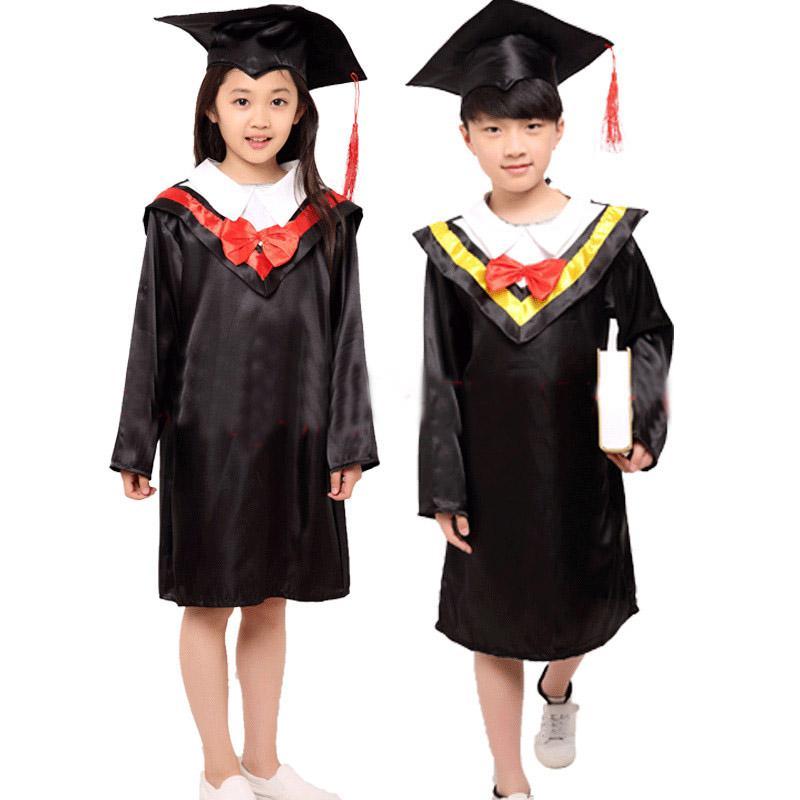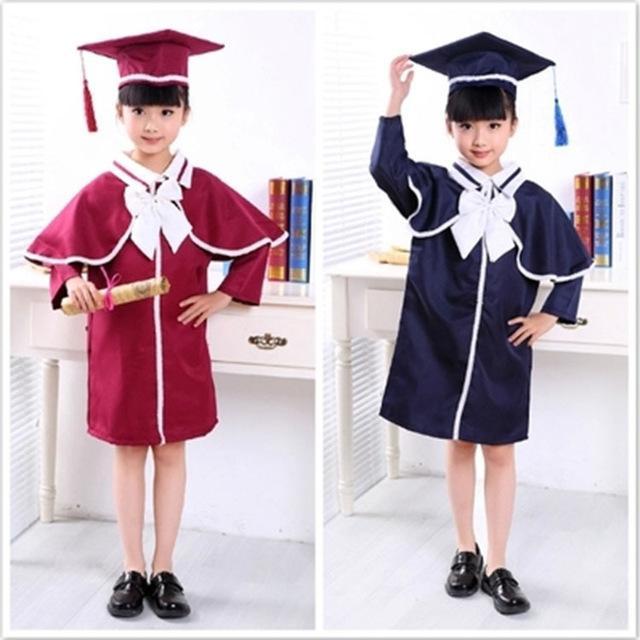The first image is the image on the left, the second image is the image on the right. Given the left and right images, does the statement "A student is holding a diploma with her left hand and pointing with her right hand." hold true? Answer yes or no. No. The first image is the image on the left, the second image is the image on the right. Considering the images on both sides, is "Someone is carrying a book next to someone who isn't carrying a book." valid? Answer yes or no. Yes. 